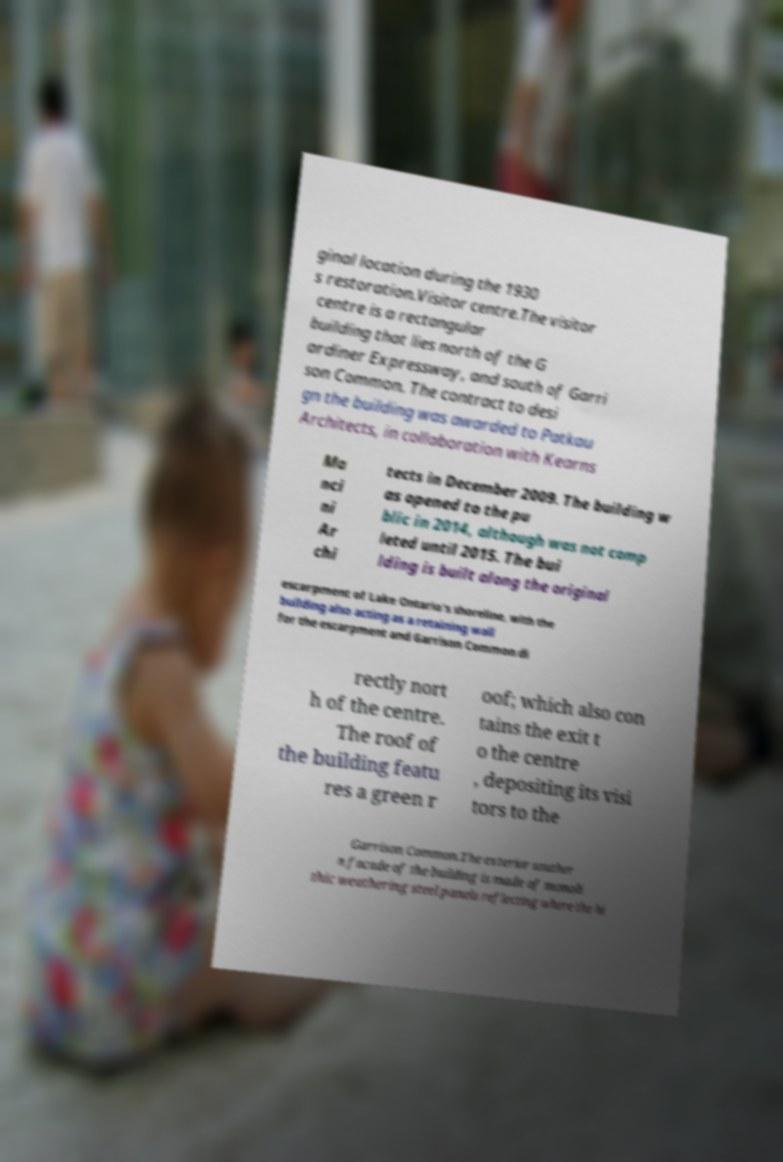I need the written content from this picture converted into text. Can you do that? ginal location during the 1930 s restoration.Visitor centre.The visitor centre is a rectangular building that lies north of the G ardiner Expressway, and south of Garri son Common. The contract to desi gn the building was awarded to Patkau Architects, in collaboration with Kearns Ma nci ni Ar chi tects in December 2009. The building w as opened to the pu blic in 2014, although was not comp leted until 2015. The bui lding is built along the original escarpment of Lake Ontario's shoreline, with the building also acting as a retaining wall for the escarpment and Garrison Common di rectly nort h of the centre. The roof of the building featu res a green r oof; which also con tains the exit t o the centre , depositing its visi tors to the Garrison Common.The exterior souther n facade of the building is made of monoli thic weathering steel panels reflecting where the hi 